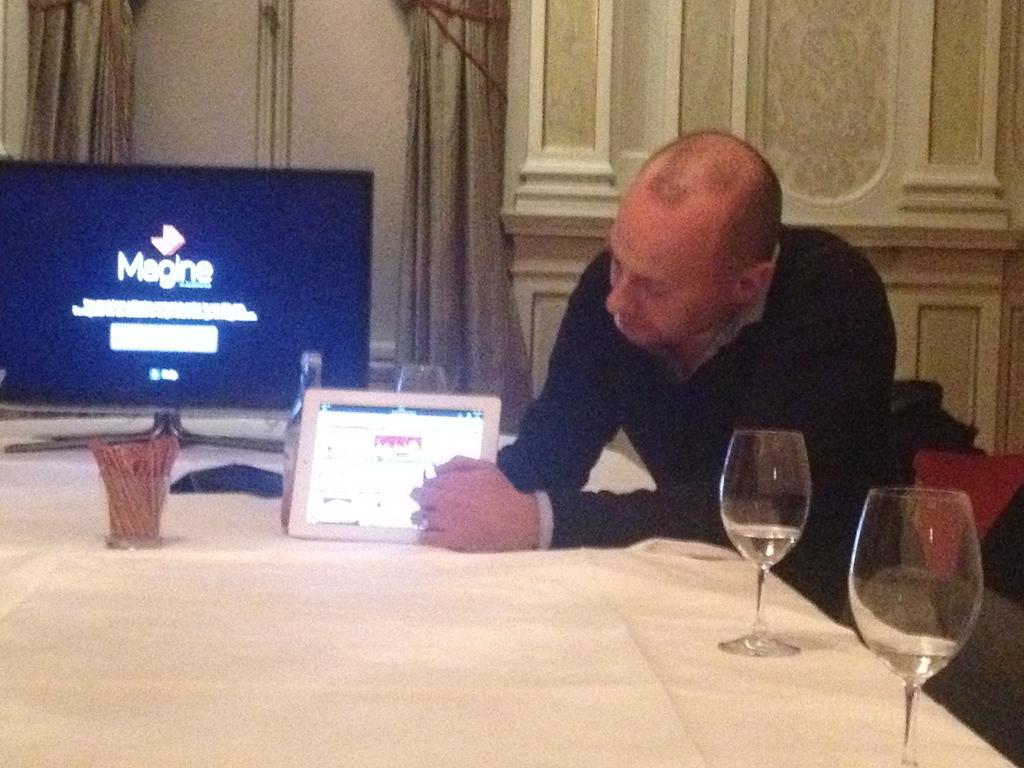Can you describe this image briefly? In this picture there is a man sitting on the table with a white color cloth on the table. There are two glasses on it. The man is explaining in the tablet. In the background , there is a television and magazine is written on it. There are also curtains and a decorated wall in the background. 